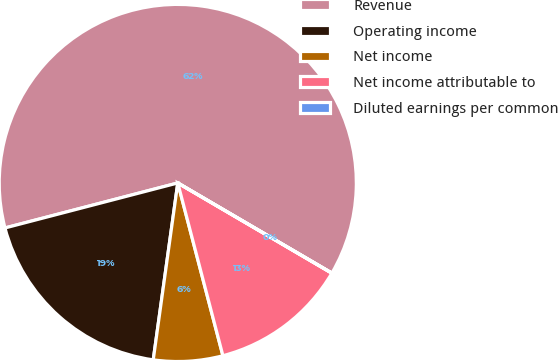Convert chart to OTSL. <chart><loc_0><loc_0><loc_500><loc_500><pie_chart><fcel>Revenue<fcel>Operating income<fcel>Net income<fcel>Net income attributable to<fcel>Diluted earnings per common<nl><fcel>62.47%<fcel>18.75%<fcel>6.26%<fcel>12.5%<fcel>0.01%<nl></chart> 